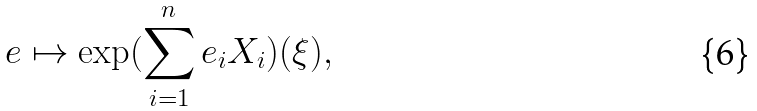Convert formula to latex. <formula><loc_0><loc_0><loc_500><loc_500>e \mapsto \exp ( \sum _ { i = 1 } ^ { n } e _ { i } X _ { i } ) ( \xi ) ,</formula> 